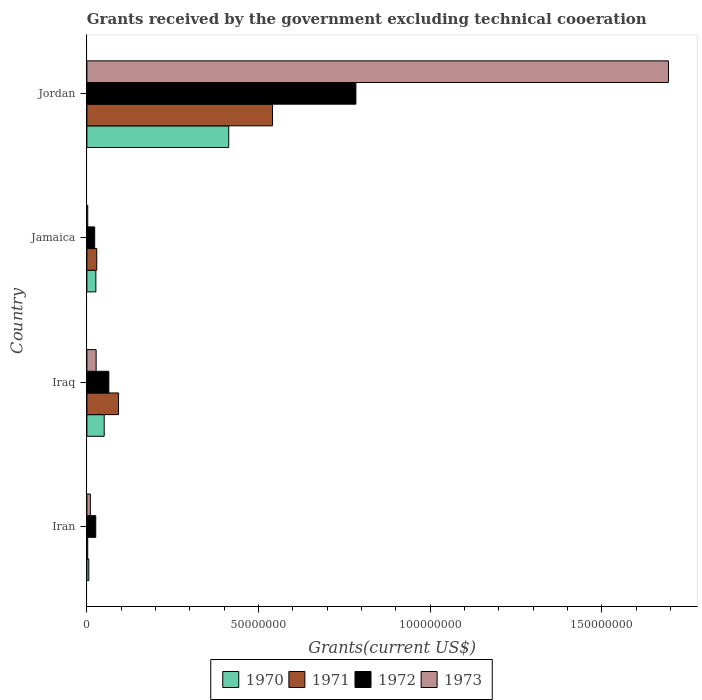What is the label of the 3rd group of bars from the top?
Give a very brief answer. Iraq. What is the total grants received by the government in 1972 in Iraq?
Offer a terse response. 6.39e+06. Across all countries, what is the maximum total grants received by the government in 1971?
Give a very brief answer. 5.41e+07. In which country was the total grants received by the government in 1971 maximum?
Make the answer very short. Jordan. In which country was the total grants received by the government in 1970 minimum?
Provide a short and direct response. Iran. What is the total total grants received by the government in 1970 in the graph?
Provide a succinct answer. 4.95e+07. What is the difference between the total grants received by the government in 1970 in Jamaica and that in Jordan?
Make the answer very short. -3.87e+07. What is the difference between the total grants received by the government in 1970 in Jordan and the total grants received by the government in 1973 in Iran?
Give a very brief answer. 4.03e+07. What is the average total grants received by the government in 1971 per country?
Offer a terse response. 1.66e+07. In how many countries, is the total grants received by the government in 1970 greater than 60000000 US$?
Provide a succinct answer. 0. What is the ratio of the total grants received by the government in 1971 in Iran to that in Jamaica?
Make the answer very short. 0.08. What is the difference between the highest and the second highest total grants received by the government in 1971?
Offer a terse response. 4.49e+07. What is the difference between the highest and the lowest total grants received by the government in 1972?
Give a very brief answer. 7.61e+07. In how many countries, is the total grants received by the government in 1971 greater than the average total grants received by the government in 1971 taken over all countries?
Offer a terse response. 1. Is the sum of the total grants received by the government in 1973 in Jamaica and Jordan greater than the maximum total grants received by the government in 1971 across all countries?
Offer a very short reply. Yes. Is it the case that in every country, the sum of the total grants received by the government in 1970 and total grants received by the government in 1972 is greater than the sum of total grants received by the government in 1971 and total grants received by the government in 1973?
Offer a terse response. No. What does the 1st bar from the top in Jordan represents?
Make the answer very short. 1973. Are all the bars in the graph horizontal?
Make the answer very short. Yes. How many countries are there in the graph?
Provide a succinct answer. 4. What is the difference between two consecutive major ticks on the X-axis?
Your response must be concise. 5.00e+07. Does the graph contain any zero values?
Ensure brevity in your answer.  No. How many legend labels are there?
Keep it short and to the point. 4. What is the title of the graph?
Your response must be concise. Grants received by the government excluding technical cooeration. What is the label or title of the X-axis?
Offer a very short reply. Grants(current US$). What is the label or title of the Y-axis?
Offer a terse response. Country. What is the Grants(current US$) in 1970 in Iran?
Offer a terse response. 5.60e+05. What is the Grants(current US$) of 1972 in Iran?
Keep it short and to the point. 2.58e+06. What is the Grants(current US$) of 1973 in Iran?
Keep it short and to the point. 1.01e+06. What is the Grants(current US$) in 1970 in Iraq?
Provide a short and direct response. 5.04e+06. What is the Grants(current US$) of 1971 in Iraq?
Provide a succinct answer. 9.20e+06. What is the Grants(current US$) in 1972 in Iraq?
Your response must be concise. 6.39e+06. What is the Grants(current US$) in 1973 in Iraq?
Offer a very short reply. 2.69e+06. What is the Grants(current US$) in 1970 in Jamaica?
Keep it short and to the point. 2.61e+06. What is the Grants(current US$) in 1971 in Jamaica?
Your answer should be very brief. 2.87e+06. What is the Grants(current US$) in 1972 in Jamaica?
Your answer should be very brief. 2.27e+06. What is the Grants(current US$) in 1973 in Jamaica?
Provide a succinct answer. 2.50e+05. What is the Grants(current US$) of 1970 in Jordan?
Give a very brief answer. 4.13e+07. What is the Grants(current US$) in 1971 in Jordan?
Your answer should be very brief. 5.41e+07. What is the Grants(current US$) in 1972 in Jordan?
Offer a terse response. 7.84e+07. What is the Grants(current US$) in 1973 in Jordan?
Provide a succinct answer. 1.69e+08. Across all countries, what is the maximum Grants(current US$) in 1970?
Provide a succinct answer. 4.13e+07. Across all countries, what is the maximum Grants(current US$) in 1971?
Your answer should be very brief. 5.41e+07. Across all countries, what is the maximum Grants(current US$) in 1972?
Ensure brevity in your answer.  7.84e+07. Across all countries, what is the maximum Grants(current US$) in 1973?
Your answer should be very brief. 1.69e+08. Across all countries, what is the minimum Grants(current US$) of 1970?
Your answer should be compact. 5.60e+05. Across all countries, what is the minimum Grants(current US$) in 1972?
Make the answer very short. 2.27e+06. Across all countries, what is the minimum Grants(current US$) in 1973?
Provide a short and direct response. 2.50e+05. What is the total Grants(current US$) in 1970 in the graph?
Keep it short and to the point. 4.95e+07. What is the total Grants(current US$) of 1971 in the graph?
Your answer should be very brief. 6.64e+07. What is the total Grants(current US$) in 1972 in the graph?
Your answer should be very brief. 8.96e+07. What is the total Grants(current US$) of 1973 in the graph?
Make the answer very short. 1.73e+08. What is the difference between the Grants(current US$) of 1970 in Iran and that in Iraq?
Ensure brevity in your answer.  -4.48e+06. What is the difference between the Grants(current US$) of 1971 in Iran and that in Iraq?
Ensure brevity in your answer.  -8.96e+06. What is the difference between the Grants(current US$) in 1972 in Iran and that in Iraq?
Offer a terse response. -3.81e+06. What is the difference between the Grants(current US$) in 1973 in Iran and that in Iraq?
Ensure brevity in your answer.  -1.68e+06. What is the difference between the Grants(current US$) of 1970 in Iran and that in Jamaica?
Your answer should be very brief. -2.05e+06. What is the difference between the Grants(current US$) of 1971 in Iran and that in Jamaica?
Ensure brevity in your answer.  -2.63e+06. What is the difference between the Grants(current US$) of 1973 in Iran and that in Jamaica?
Ensure brevity in your answer.  7.60e+05. What is the difference between the Grants(current US$) in 1970 in Iran and that in Jordan?
Provide a short and direct response. -4.08e+07. What is the difference between the Grants(current US$) of 1971 in Iran and that in Jordan?
Offer a terse response. -5.38e+07. What is the difference between the Grants(current US$) of 1972 in Iran and that in Jordan?
Give a very brief answer. -7.58e+07. What is the difference between the Grants(current US$) in 1973 in Iran and that in Jordan?
Provide a short and direct response. -1.68e+08. What is the difference between the Grants(current US$) of 1970 in Iraq and that in Jamaica?
Your answer should be very brief. 2.43e+06. What is the difference between the Grants(current US$) in 1971 in Iraq and that in Jamaica?
Offer a very short reply. 6.33e+06. What is the difference between the Grants(current US$) in 1972 in Iraq and that in Jamaica?
Keep it short and to the point. 4.12e+06. What is the difference between the Grants(current US$) in 1973 in Iraq and that in Jamaica?
Make the answer very short. 2.44e+06. What is the difference between the Grants(current US$) in 1970 in Iraq and that in Jordan?
Offer a very short reply. -3.63e+07. What is the difference between the Grants(current US$) in 1971 in Iraq and that in Jordan?
Offer a terse response. -4.49e+07. What is the difference between the Grants(current US$) in 1972 in Iraq and that in Jordan?
Make the answer very short. -7.20e+07. What is the difference between the Grants(current US$) of 1973 in Iraq and that in Jordan?
Ensure brevity in your answer.  -1.67e+08. What is the difference between the Grants(current US$) in 1970 in Jamaica and that in Jordan?
Make the answer very short. -3.87e+07. What is the difference between the Grants(current US$) in 1971 in Jamaica and that in Jordan?
Your answer should be very brief. -5.12e+07. What is the difference between the Grants(current US$) of 1972 in Jamaica and that in Jordan?
Ensure brevity in your answer.  -7.61e+07. What is the difference between the Grants(current US$) in 1973 in Jamaica and that in Jordan?
Your answer should be compact. -1.69e+08. What is the difference between the Grants(current US$) in 1970 in Iran and the Grants(current US$) in 1971 in Iraq?
Provide a succinct answer. -8.64e+06. What is the difference between the Grants(current US$) in 1970 in Iran and the Grants(current US$) in 1972 in Iraq?
Give a very brief answer. -5.83e+06. What is the difference between the Grants(current US$) in 1970 in Iran and the Grants(current US$) in 1973 in Iraq?
Your answer should be very brief. -2.13e+06. What is the difference between the Grants(current US$) of 1971 in Iran and the Grants(current US$) of 1972 in Iraq?
Ensure brevity in your answer.  -6.15e+06. What is the difference between the Grants(current US$) of 1971 in Iran and the Grants(current US$) of 1973 in Iraq?
Your answer should be very brief. -2.45e+06. What is the difference between the Grants(current US$) in 1970 in Iran and the Grants(current US$) in 1971 in Jamaica?
Your answer should be compact. -2.31e+06. What is the difference between the Grants(current US$) of 1970 in Iran and the Grants(current US$) of 1972 in Jamaica?
Provide a short and direct response. -1.71e+06. What is the difference between the Grants(current US$) of 1970 in Iran and the Grants(current US$) of 1973 in Jamaica?
Ensure brevity in your answer.  3.10e+05. What is the difference between the Grants(current US$) of 1971 in Iran and the Grants(current US$) of 1972 in Jamaica?
Your answer should be very brief. -2.03e+06. What is the difference between the Grants(current US$) of 1972 in Iran and the Grants(current US$) of 1973 in Jamaica?
Ensure brevity in your answer.  2.33e+06. What is the difference between the Grants(current US$) in 1970 in Iran and the Grants(current US$) in 1971 in Jordan?
Offer a very short reply. -5.35e+07. What is the difference between the Grants(current US$) of 1970 in Iran and the Grants(current US$) of 1972 in Jordan?
Ensure brevity in your answer.  -7.78e+07. What is the difference between the Grants(current US$) of 1970 in Iran and the Grants(current US$) of 1973 in Jordan?
Keep it short and to the point. -1.69e+08. What is the difference between the Grants(current US$) in 1971 in Iran and the Grants(current US$) in 1972 in Jordan?
Your response must be concise. -7.81e+07. What is the difference between the Grants(current US$) of 1971 in Iran and the Grants(current US$) of 1973 in Jordan?
Offer a very short reply. -1.69e+08. What is the difference between the Grants(current US$) of 1972 in Iran and the Grants(current US$) of 1973 in Jordan?
Your answer should be compact. -1.67e+08. What is the difference between the Grants(current US$) in 1970 in Iraq and the Grants(current US$) in 1971 in Jamaica?
Give a very brief answer. 2.17e+06. What is the difference between the Grants(current US$) in 1970 in Iraq and the Grants(current US$) in 1972 in Jamaica?
Give a very brief answer. 2.77e+06. What is the difference between the Grants(current US$) in 1970 in Iraq and the Grants(current US$) in 1973 in Jamaica?
Make the answer very short. 4.79e+06. What is the difference between the Grants(current US$) in 1971 in Iraq and the Grants(current US$) in 1972 in Jamaica?
Keep it short and to the point. 6.93e+06. What is the difference between the Grants(current US$) in 1971 in Iraq and the Grants(current US$) in 1973 in Jamaica?
Offer a terse response. 8.95e+06. What is the difference between the Grants(current US$) of 1972 in Iraq and the Grants(current US$) of 1973 in Jamaica?
Your answer should be compact. 6.14e+06. What is the difference between the Grants(current US$) of 1970 in Iraq and the Grants(current US$) of 1971 in Jordan?
Your answer should be very brief. -4.90e+07. What is the difference between the Grants(current US$) of 1970 in Iraq and the Grants(current US$) of 1972 in Jordan?
Ensure brevity in your answer.  -7.33e+07. What is the difference between the Grants(current US$) in 1970 in Iraq and the Grants(current US$) in 1973 in Jordan?
Your answer should be very brief. -1.64e+08. What is the difference between the Grants(current US$) of 1971 in Iraq and the Grants(current US$) of 1972 in Jordan?
Offer a terse response. -6.92e+07. What is the difference between the Grants(current US$) in 1971 in Iraq and the Grants(current US$) in 1973 in Jordan?
Offer a terse response. -1.60e+08. What is the difference between the Grants(current US$) of 1972 in Iraq and the Grants(current US$) of 1973 in Jordan?
Give a very brief answer. -1.63e+08. What is the difference between the Grants(current US$) in 1970 in Jamaica and the Grants(current US$) in 1971 in Jordan?
Your response must be concise. -5.14e+07. What is the difference between the Grants(current US$) of 1970 in Jamaica and the Grants(current US$) of 1972 in Jordan?
Make the answer very short. -7.57e+07. What is the difference between the Grants(current US$) in 1970 in Jamaica and the Grants(current US$) in 1973 in Jordan?
Your answer should be compact. -1.67e+08. What is the difference between the Grants(current US$) of 1971 in Jamaica and the Grants(current US$) of 1972 in Jordan?
Offer a terse response. -7.55e+07. What is the difference between the Grants(current US$) in 1971 in Jamaica and the Grants(current US$) in 1973 in Jordan?
Your answer should be compact. -1.67e+08. What is the difference between the Grants(current US$) of 1972 in Jamaica and the Grants(current US$) of 1973 in Jordan?
Provide a succinct answer. -1.67e+08. What is the average Grants(current US$) in 1970 per country?
Your response must be concise. 1.24e+07. What is the average Grants(current US$) of 1971 per country?
Provide a succinct answer. 1.66e+07. What is the average Grants(current US$) of 1972 per country?
Your response must be concise. 2.24e+07. What is the average Grants(current US$) of 1973 per country?
Your answer should be compact. 4.33e+07. What is the difference between the Grants(current US$) of 1970 and Grants(current US$) of 1971 in Iran?
Make the answer very short. 3.20e+05. What is the difference between the Grants(current US$) in 1970 and Grants(current US$) in 1972 in Iran?
Give a very brief answer. -2.02e+06. What is the difference between the Grants(current US$) in 1970 and Grants(current US$) in 1973 in Iran?
Provide a short and direct response. -4.50e+05. What is the difference between the Grants(current US$) in 1971 and Grants(current US$) in 1972 in Iran?
Offer a very short reply. -2.34e+06. What is the difference between the Grants(current US$) of 1971 and Grants(current US$) of 1973 in Iran?
Offer a very short reply. -7.70e+05. What is the difference between the Grants(current US$) in 1972 and Grants(current US$) in 1973 in Iran?
Offer a terse response. 1.57e+06. What is the difference between the Grants(current US$) in 1970 and Grants(current US$) in 1971 in Iraq?
Your response must be concise. -4.16e+06. What is the difference between the Grants(current US$) of 1970 and Grants(current US$) of 1972 in Iraq?
Your answer should be very brief. -1.35e+06. What is the difference between the Grants(current US$) in 1970 and Grants(current US$) in 1973 in Iraq?
Your answer should be very brief. 2.35e+06. What is the difference between the Grants(current US$) in 1971 and Grants(current US$) in 1972 in Iraq?
Keep it short and to the point. 2.81e+06. What is the difference between the Grants(current US$) in 1971 and Grants(current US$) in 1973 in Iraq?
Provide a short and direct response. 6.51e+06. What is the difference between the Grants(current US$) in 1972 and Grants(current US$) in 1973 in Iraq?
Your answer should be compact. 3.70e+06. What is the difference between the Grants(current US$) of 1970 and Grants(current US$) of 1971 in Jamaica?
Your answer should be very brief. -2.60e+05. What is the difference between the Grants(current US$) of 1970 and Grants(current US$) of 1973 in Jamaica?
Your answer should be compact. 2.36e+06. What is the difference between the Grants(current US$) in 1971 and Grants(current US$) in 1972 in Jamaica?
Provide a succinct answer. 6.00e+05. What is the difference between the Grants(current US$) of 1971 and Grants(current US$) of 1973 in Jamaica?
Your response must be concise. 2.62e+06. What is the difference between the Grants(current US$) in 1972 and Grants(current US$) in 1973 in Jamaica?
Offer a terse response. 2.02e+06. What is the difference between the Grants(current US$) of 1970 and Grants(current US$) of 1971 in Jordan?
Provide a short and direct response. -1.27e+07. What is the difference between the Grants(current US$) in 1970 and Grants(current US$) in 1972 in Jordan?
Offer a very short reply. -3.70e+07. What is the difference between the Grants(current US$) in 1970 and Grants(current US$) in 1973 in Jordan?
Offer a terse response. -1.28e+08. What is the difference between the Grants(current US$) in 1971 and Grants(current US$) in 1972 in Jordan?
Keep it short and to the point. -2.43e+07. What is the difference between the Grants(current US$) of 1971 and Grants(current US$) of 1973 in Jordan?
Make the answer very short. -1.15e+08. What is the difference between the Grants(current US$) of 1972 and Grants(current US$) of 1973 in Jordan?
Ensure brevity in your answer.  -9.10e+07. What is the ratio of the Grants(current US$) in 1970 in Iran to that in Iraq?
Provide a short and direct response. 0.11. What is the ratio of the Grants(current US$) of 1971 in Iran to that in Iraq?
Your answer should be compact. 0.03. What is the ratio of the Grants(current US$) in 1972 in Iran to that in Iraq?
Ensure brevity in your answer.  0.4. What is the ratio of the Grants(current US$) of 1973 in Iran to that in Iraq?
Provide a short and direct response. 0.38. What is the ratio of the Grants(current US$) of 1970 in Iran to that in Jamaica?
Offer a very short reply. 0.21. What is the ratio of the Grants(current US$) of 1971 in Iran to that in Jamaica?
Keep it short and to the point. 0.08. What is the ratio of the Grants(current US$) in 1972 in Iran to that in Jamaica?
Your answer should be very brief. 1.14. What is the ratio of the Grants(current US$) in 1973 in Iran to that in Jamaica?
Provide a succinct answer. 4.04. What is the ratio of the Grants(current US$) in 1970 in Iran to that in Jordan?
Offer a very short reply. 0.01. What is the ratio of the Grants(current US$) of 1971 in Iran to that in Jordan?
Provide a short and direct response. 0. What is the ratio of the Grants(current US$) in 1972 in Iran to that in Jordan?
Provide a succinct answer. 0.03. What is the ratio of the Grants(current US$) of 1973 in Iran to that in Jordan?
Your answer should be compact. 0.01. What is the ratio of the Grants(current US$) in 1970 in Iraq to that in Jamaica?
Keep it short and to the point. 1.93. What is the ratio of the Grants(current US$) of 1971 in Iraq to that in Jamaica?
Give a very brief answer. 3.21. What is the ratio of the Grants(current US$) of 1972 in Iraq to that in Jamaica?
Offer a very short reply. 2.81. What is the ratio of the Grants(current US$) of 1973 in Iraq to that in Jamaica?
Make the answer very short. 10.76. What is the ratio of the Grants(current US$) in 1970 in Iraq to that in Jordan?
Your answer should be compact. 0.12. What is the ratio of the Grants(current US$) of 1971 in Iraq to that in Jordan?
Offer a very short reply. 0.17. What is the ratio of the Grants(current US$) of 1972 in Iraq to that in Jordan?
Your response must be concise. 0.08. What is the ratio of the Grants(current US$) in 1973 in Iraq to that in Jordan?
Make the answer very short. 0.02. What is the ratio of the Grants(current US$) of 1970 in Jamaica to that in Jordan?
Your answer should be compact. 0.06. What is the ratio of the Grants(current US$) in 1971 in Jamaica to that in Jordan?
Offer a terse response. 0.05. What is the ratio of the Grants(current US$) in 1972 in Jamaica to that in Jordan?
Offer a terse response. 0.03. What is the ratio of the Grants(current US$) in 1973 in Jamaica to that in Jordan?
Offer a very short reply. 0. What is the difference between the highest and the second highest Grants(current US$) in 1970?
Offer a very short reply. 3.63e+07. What is the difference between the highest and the second highest Grants(current US$) in 1971?
Your response must be concise. 4.49e+07. What is the difference between the highest and the second highest Grants(current US$) of 1972?
Ensure brevity in your answer.  7.20e+07. What is the difference between the highest and the second highest Grants(current US$) in 1973?
Give a very brief answer. 1.67e+08. What is the difference between the highest and the lowest Grants(current US$) of 1970?
Offer a terse response. 4.08e+07. What is the difference between the highest and the lowest Grants(current US$) of 1971?
Provide a succinct answer. 5.38e+07. What is the difference between the highest and the lowest Grants(current US$) of 1972?
Make the answer very short. 7.61e+07. What is the difference between the highest and the lowest Grants(current US$) in 1973?
Keep it short and to the point. 1.69e+08. 